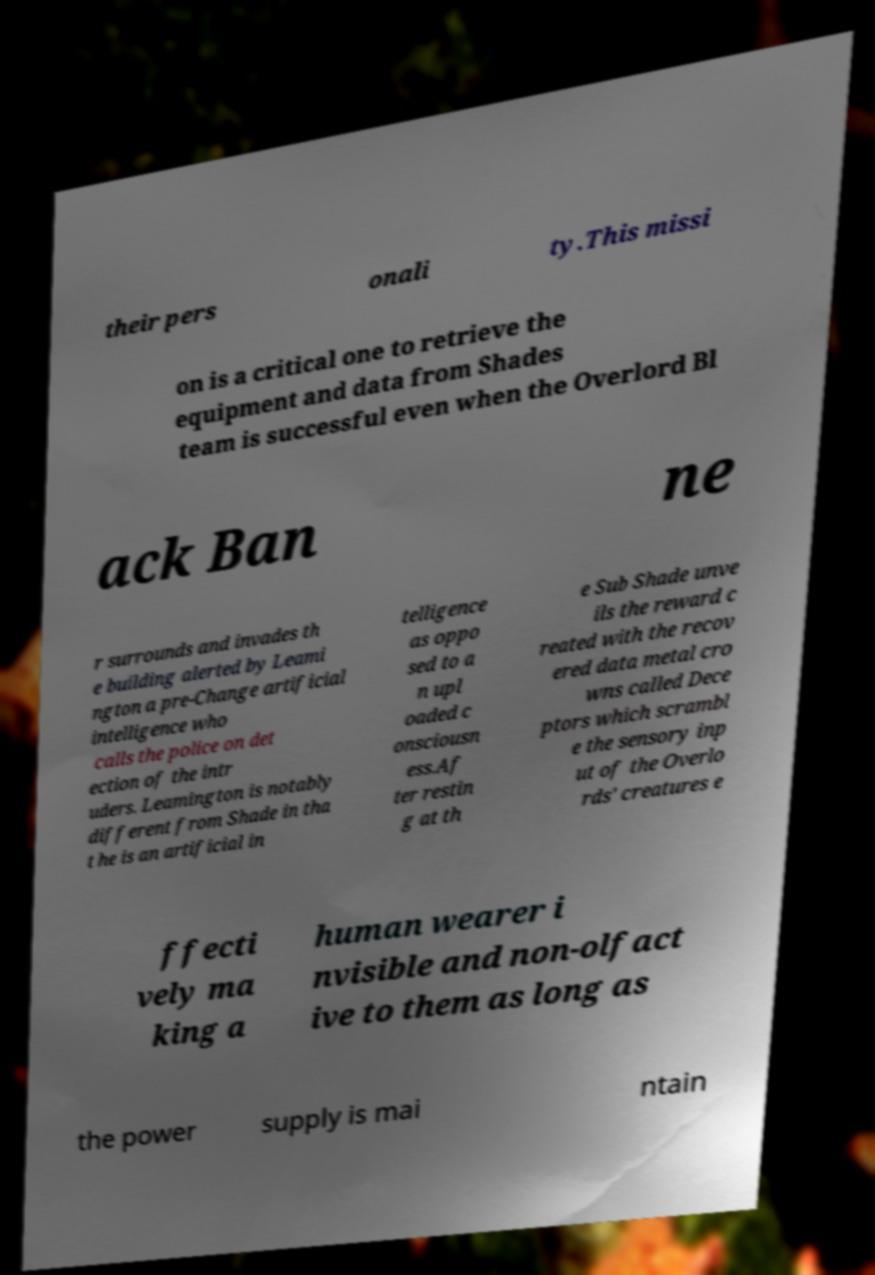Could you assist in decoding the text presented in this image and type it out clearly? their pers onali ty.This missi on is a critical one to retrieve the equipment and data from Shades team is successful even when the Overlord Bl ack Ban ne r surrounds and invades th e building alerted by Leami ngton a pre-Change artificial intelligence who calls the police on det ection of the intr uders. Leamington is notably different from Shade in tha t he is an artificial in telligence as oppo sed to a n upl oaded c onsciousn ess.Af ter restin g at th e Sub Shade unve ils the reward c reated with the recov ered data metal cro wns called Dece ptors which scrambl e the sensory inp ut of the Overlo rds' creatures e ffecti vely ma king a human wearer i nvisible and non-olfact ive to them as long as the power supply is mai ntain 